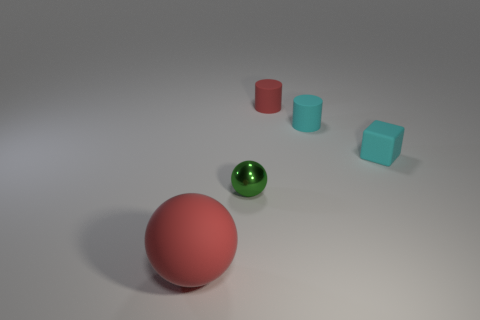Add 1 big brown spheres. How many objects exist? 6 Subtract all blocks. How many objects are left? 4 Subtract all tiny rubber cylinders. Subtract all big red matte balls. How many objects are left? 2 Add 5 large red rubber balls. How many large red rubber balls are left? 6 Add 2 small cyan matte objects. How many small cyan matte objects exist? 4 Subtract 0 gray cylinders. How many objects are left? 5 